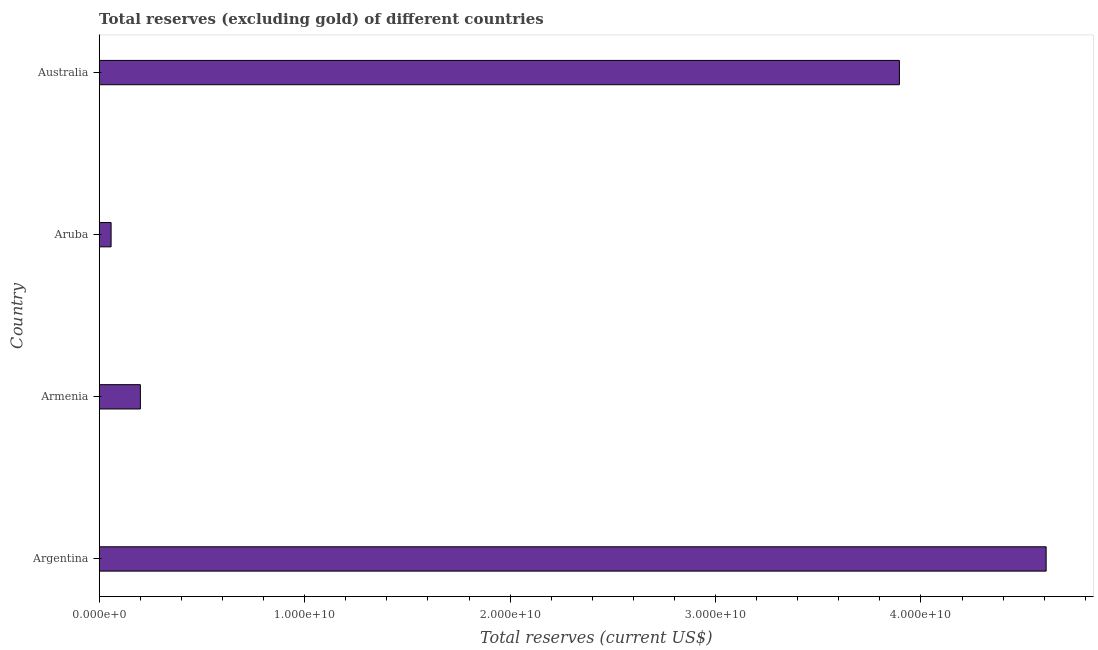Does the graph contain any zero values?
Offer a very short reply. No. What is the title of the graph?
Your response must be concise. Total reserves (excluding gold) of different countries. What is the label or title of the X-axis?
Give a very brief answer. Total reserves (current US$). What is the total reserves (excluding gold) in Aruba?
Your response must be concise. 5.78e+08. Across all countries, what is the maximum total reserves (excluding gold)?
Provide a succinct answer. 4.61e+1. Across all countries, what is the minimum total reserves (excluding gold)?
Offer a very short reply. 5.78e+08. In which country was the total reserves (excluding gold) minimum?
Your response must be concise. Aruba. What is the sum of the total reserves (excluding gold)?
Your response must be concise. 8.76e+1. What is the difference between the total reserves (excluding gold) in Armenia and Aruba?
Offer a very short reply. 1.43e+09. What is the average total reserves (excluding gold) per country?
Offer a terse response. 2.19e+1. What is the median total reserves (excluding gold)?
Offer a very short reply. 2.05e+1. What is the ratio of the total reserves (excluding gold) in Argentina to that in Aruba?
Your response must be concise. 79.72. Is the difference between the total reserves (excluding gold) in Argentina and Armenia greater than the difference between any two countries?
Give a very brief answer. No. What is the difference between the highest and the second highest total reserves (excluding gold)?
Offer a terse response. 7.14e+09. Is the sum of the total reserves (excluding gold) in Armenia and Aruba greater than the maximum total reserves (excluding gold) across all countries?
Ensure brevity in your answer.  No. What is the difference between the highest and the lowest total reserves (excluding gold)?
Provide a succinct answer. 4.55e+1. In how many countries, is the total reserves (excluding gold) greater than the average total reserves (excluding gold) taken over all countries?
Offer a very short reply. 2. How many countries are there in the graph?
Your answer should be very brief. 4. What is the difference between two consecutive major ticks on the X-axis?
Your answer should be compact. 1.00e+1. Are the values on the major ticks of X-axis written in scientific E-notation?
Your answer should be compact. Yes. What is the Total reserves (current US$) in Argentina?
Your answer should be compact. 4.61e+1. What is the Total reserves (current US$) of Armenia?
Give a very brief answer. 2.00e+09. What is the Total reserves (current US$) in Aruba?
Offer a very short reply. 5.78e+08. What is the Total reserves (current US$) in Australia?
Give a very brief answer. 3.90e+1. What is the difference between the Total reserves (current US$) in Argentina and Armenia?
Provide a short and direct response. 4.41e+1. What is the difference between the Total reserves (current US$) in Argentina and Aruba?
Ensure brevity in your answer.  4.55e+1. What is the difference between the Total reserves (current US$) in Argentina and Australia?
Ensure brevity in your answer.  7.14e+09. What is the difference between the Total reserves (current US$) in Armenia and Aruba?
Offer a terse response. 1.43e+09. What is the difference between the Total reserves (current US$) in Armenia and Australia?
Make the answer very short. -3.69e+1. What is the difference between the Total reserves (current US$) in Aruba and Australia?
Make the answer very short. -3.84e+1. What is the ratio of the Total reserves (current US$) in Argentina to that in Armenia?
Provide a succinct answer. 23. What is the ratio of the Total reserves (current US$) in Argentina to that in Aruba?
Offer a terse response. 79.72. What is the ratio of the Total reserves (current US$) in Argentina to that in Australia?
Make the answer very short. 1.18. What is the ratio of the Total reserves (current US$) in Armenia to that in Aruba?
Provide a succinct answer. 3.46. What is the ratio of the Total reserves (current US$) in Armenia to that in Australia?
Keep it short and to the point. 0.05. What is the ratio of the Total reserves (current US$) in Aruba to that in Australia?
Provide a succinct answer. 0.01. 